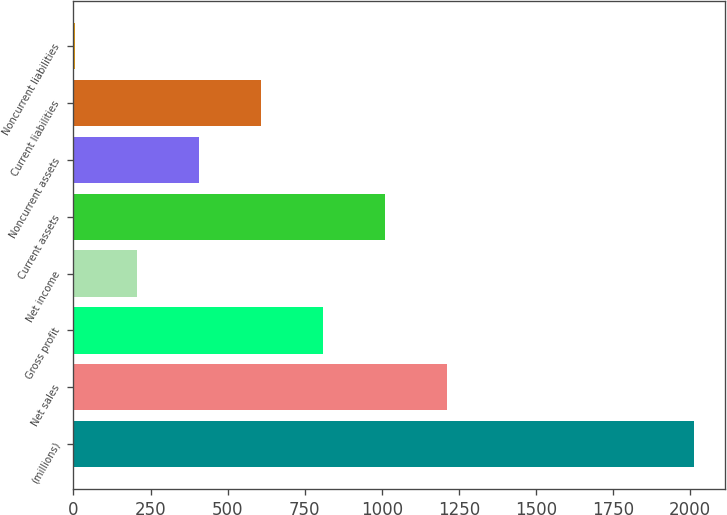Convert chart. <chart><loc_0><loc_0><loc_500><loc_500><bar_chart><fcel>(millions)<fcel>Net sales<fcel>Gross profit<fcel>Net income<fcel>Current assets<fcel>Noncurrent assets<fcel>Current liabilities<fcel>Noncurrent liabilities<nl><fcel>2014<fcel>1210.92<fcel>809.38<fcel>207.07<fcel>1010.15<fcel>407.84<fcel>608.61<fcel>6.3<nl></chart> 